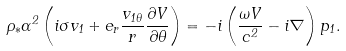Convert formula to latex. <formula><loc_0><loc_0><loc_500><loc_500>\rho _ { * } \Gamma ^ { 2 } \left ( i \sigma { v } _ { 1 } + { e } _ { r } \frac { v _ { 1 \theta } } { r } \frac { \partial V } { \partial \theta } \right ) = - i \left ( \frac { \omega { V } } { c ^ { 2 } } - i \nabla \right ) p _ { 1 } .</formula> 